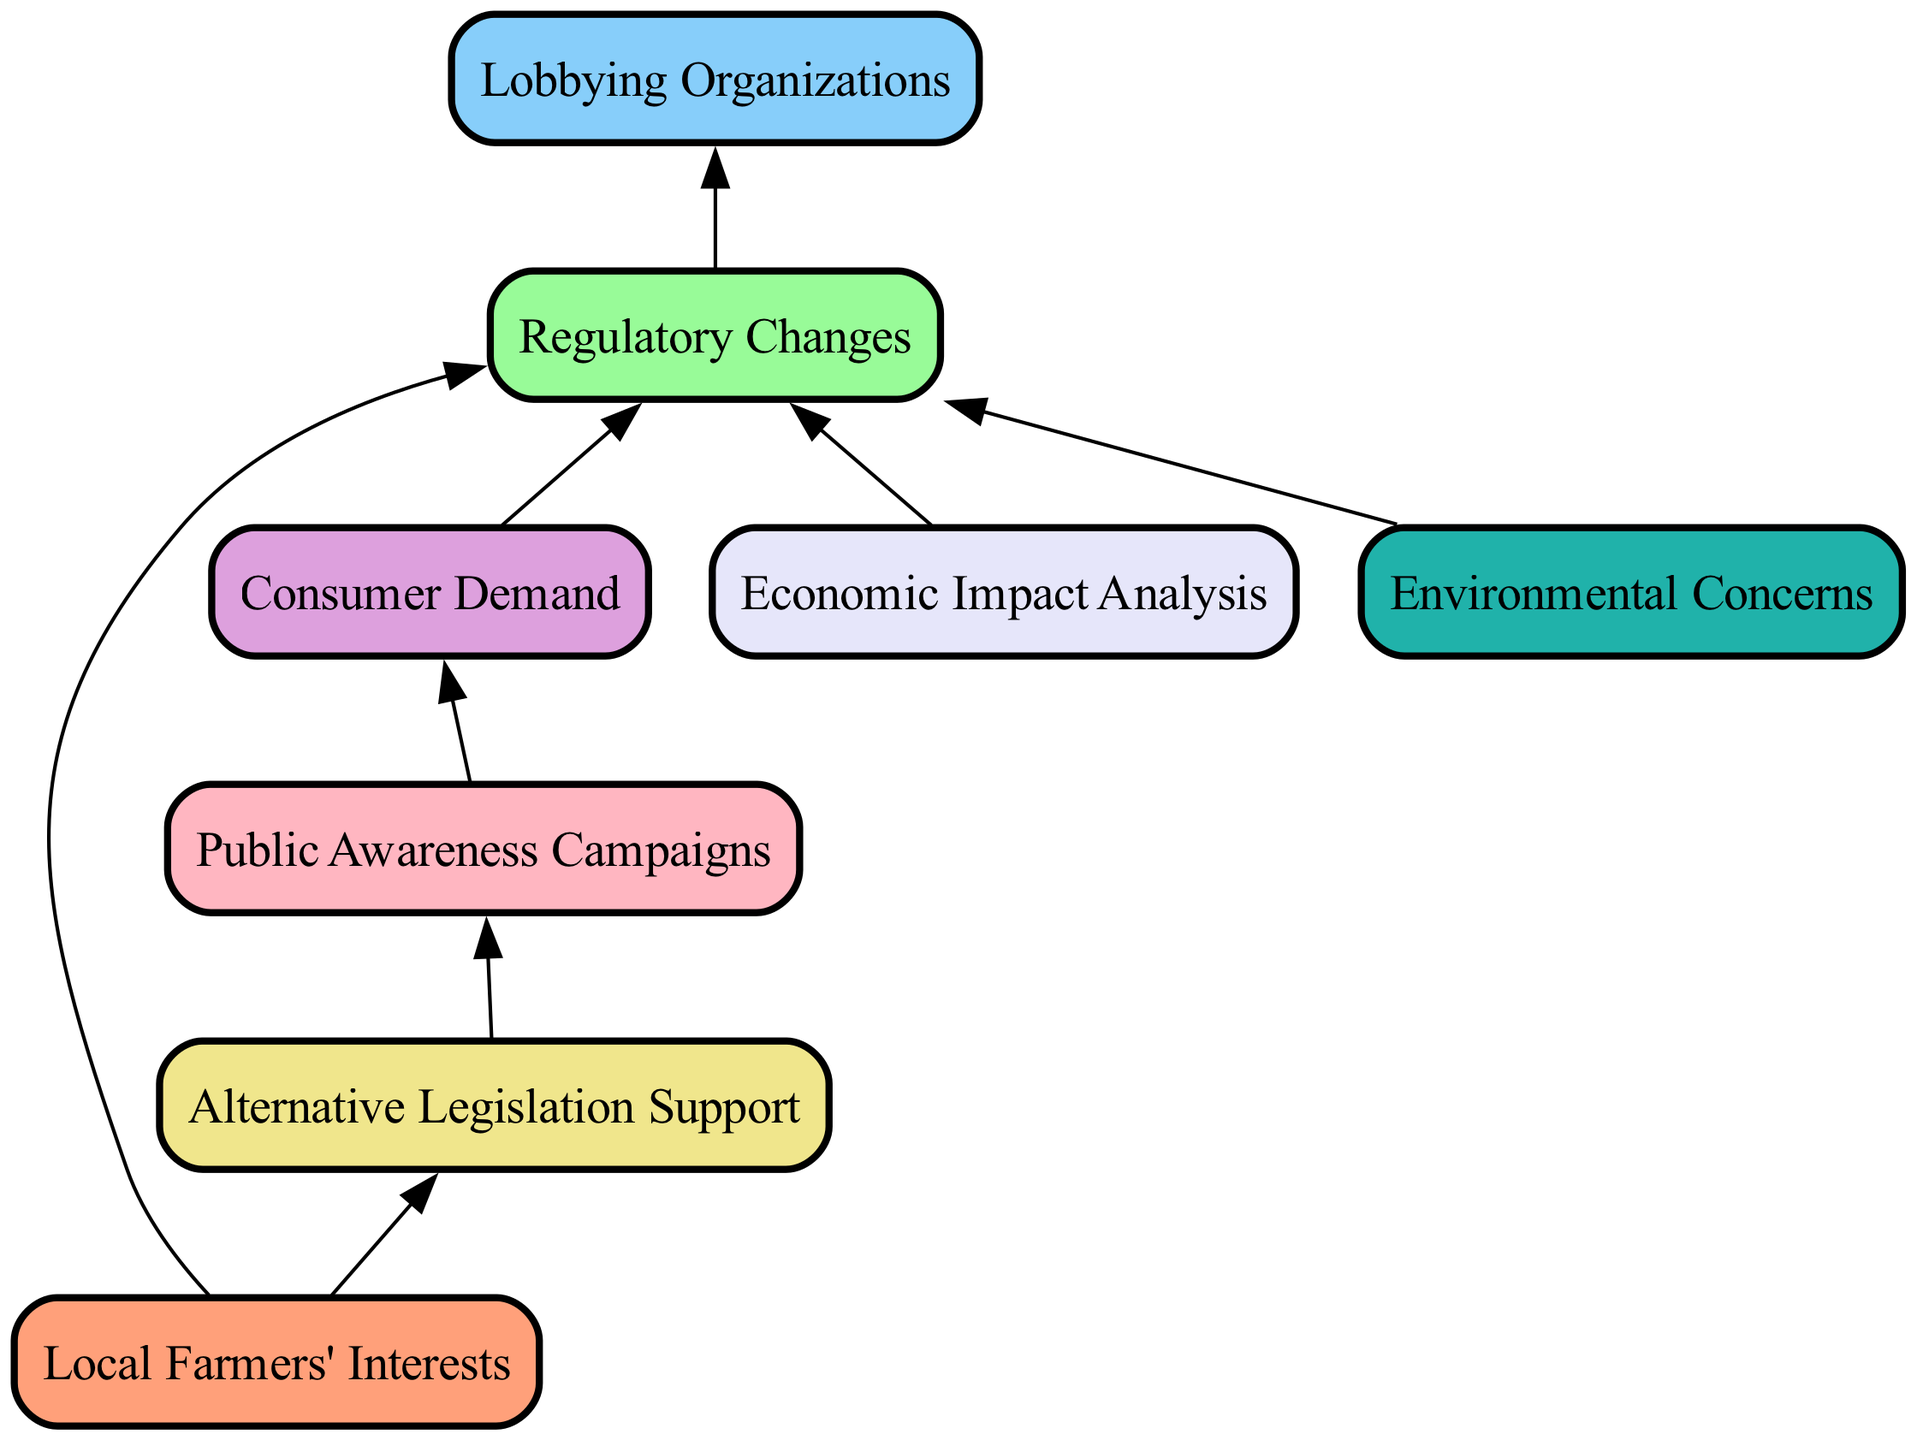What are the local farmers' interests? The diagram identifies "Local Farmers' Interests" as the core focus of farmer concerns and needs regarding livestock regulations, signifying its importance at the bottom of the flow chart.
Answer: Local Farmers' Interests How many nodes are in the diagram? By counting all unique elements in the flow chart, we find there are eight nodes connected through various relationships.
Answer: 8 Which group influences regulatory changes? The diagram shows that "Lobbying Organizations" are connected to "Regulatory Changes," indicating their influence in this context.
Answer: Lobbying Organizations What supports alternative legislation? "Local Farmers' Interests" directly leads to "Alternative Legislation Support," showing that farmers are a driving force behind this support.
Answer: Local Farmers' Interests How are public awareness campaigns related to consumer demand? The diagram illustrates a direct edge from "Public Awareness Campaigns" to "Consumer Demand," indicating that awareness campaigns aim to inform or influence consumer preferences.
Answer: Public Awareness Campaigns Which node has the most edges connecting to it? By analyzing the connections, "Regulatory Changes" has the most edges leading to it, indicating it's central to the diagram’s flow of information.
Answer: Regulatory Changes What influences regulatory changes due to environmental concerns? "Environmental Concerns" leads to "Regulatory Changes," illustrating that concerns about sustainability affect regulation decisions.
Answer: Environmental Concerns Which two nodes are directly connected? "Public Awareness Campaigns" is directly connected to "Consumer Demand," showing a clear relationship in the flow of influence.
Answer: Public Awareness Campaigns and Consumer Demand What is the role of economic impact analysis? The node "Economic Impact Analysis" affects "Regulatory Changes," suggesting its function is to assess the economic implications of proposed regulations.
Answer: Economic Impact Analysis 